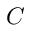<formula> <loc_0><loc_0><loc_500><loc_500>C</formula> 